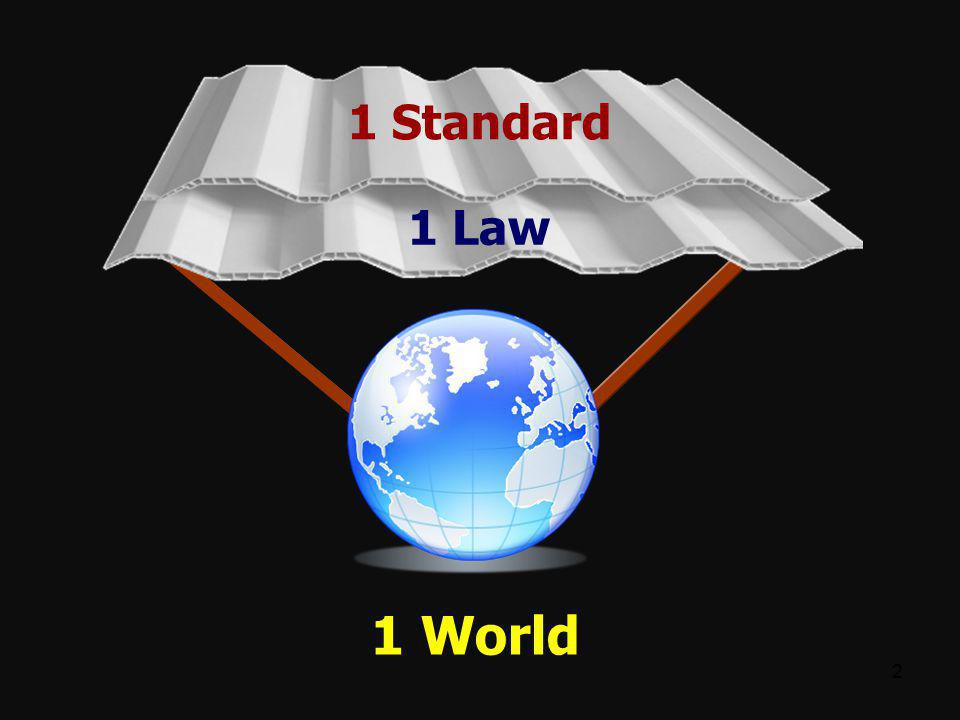Imagine this image is part of an alien communication explaining their planetary governance to humans. How would that conversation go? Alien: Greetings, humans of Earth. Our civilization thrives on the principles depicted in this image. We embrace the ethos of '1 Standard', '1 Law', and '1 World'. This unified approach has fostered peace, equality, and progress on our planet for millennia.

Human: Fascinating! Can you explain how a single standard and law work without suppressing diversity?

Alien: Indeed, diversity is celebrated within our framework. Our single standard encompasses fundamental rights and duties, ensuring fairness for all. Our single law addresses common good, while allowing cultural and regional diversities to flourish within it, much like various flowers blooming harmoniously in a single garden.

Human: Incredible! How can we adopt such a system on Earth?

Alien: It requires a shift in mindset. Embrace the commonalities that bind humanity, while respecting and nurturing unique identities. It’s a gradual process of mutual understanding, dialogue, and collaboration across the globe. 